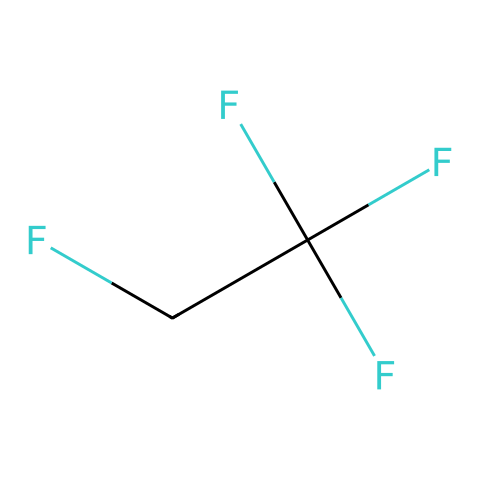What is the name of this refrigerant? The SMILES representation (FC(F)(F)CF) indicates that the chemical structure corresponds to 1,1,1,2-Tetrafluoroethane, commonly known as R-134a.
Answer: R-134a How many carbon atoms are present in R-134a? From the SMILES notation, we can see 'C' appears two times, indicating that there are two carbon atoms in the structure of R-134a.
Answer: 2 What is the total number of fluorine atoms in R-134a? In the SMILES structure, 'F' appears three times, indicating that there are three fluorine atoms attached to the carbon backbone of R-134a.
Answer: 3 Is R-134a considered a greenhouse gas? R-134a is classified as a greenhouse gas due to its potential to trap heat in the atmosphere, mainly because of its fluorinated compounds that persist over time.
Answer: Yes What type of functional group does R-134a belong to? Based on the chemical structure, R-134a has a fully saturated carbon backbone with fluorine substituents and no double bonds, categorizing it as a haloalkane or halocarbon.
Answer: Haloalkane What property of R-134a makes it suitable for use in car air conditioning systems? R-134a has a low boiling point and good thermodynamic properties, allowing it to efficiently absorb heat at lower temperatures, which is essential for refrigeration applications like car air conditioning.
Answer: Low boiling point How many hydrogen atoms are in R-134a? By analyzing the structure, the carbon atoms in R-134a are fully substituted with fluorine and only one hydrogen atom is shown on the secondary carbon, giving a total of two hydrogen atoms in the compound.
Answer: 2 